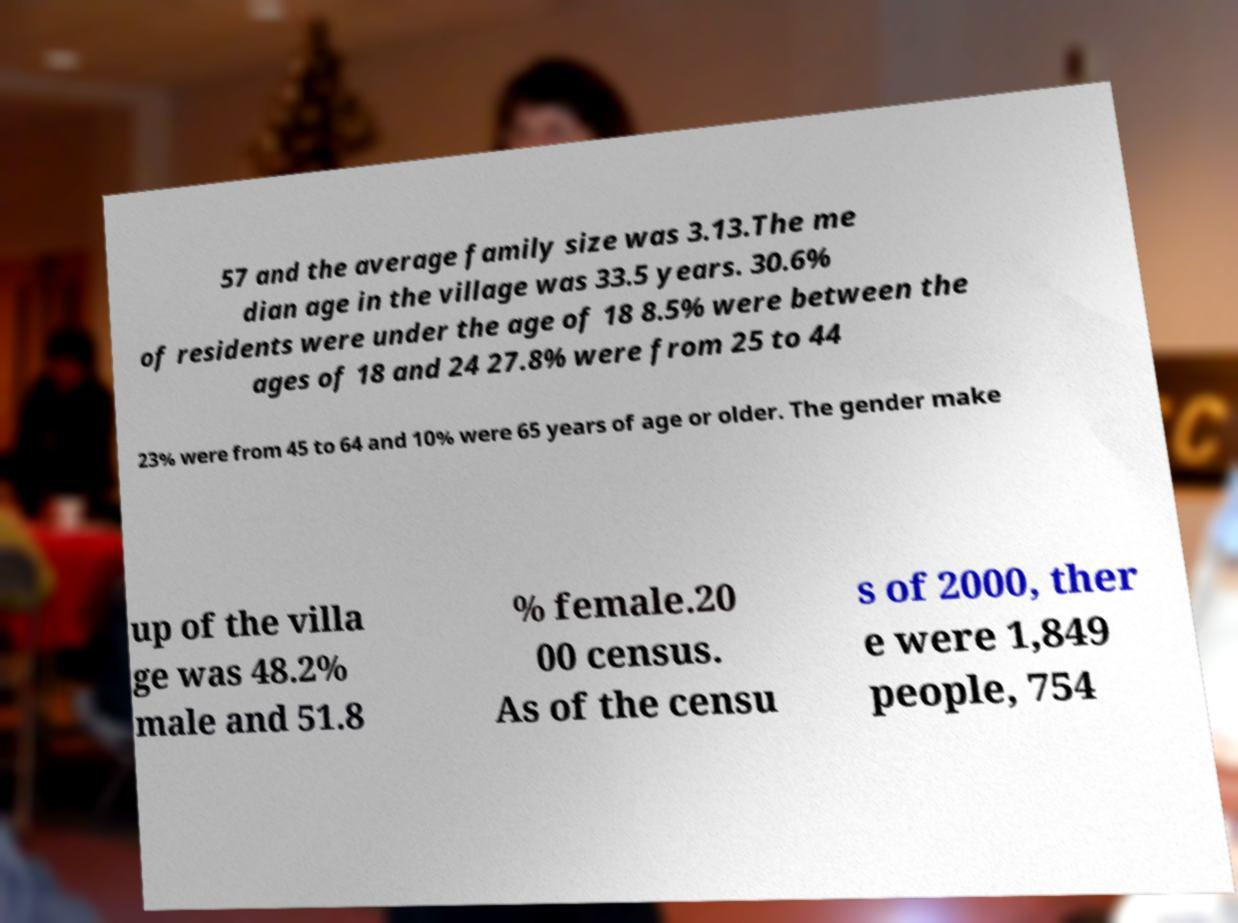Could you assist in decoding the text presented in this image and type it out clearly? 57 and the average family size was 3.13.The me dian age in the village was 33.5 years. 30.6% of residents were under the age of 18 8.5% were between the ages of 18 and 24 27.8% were from 25 to 44 23% were from 45 to 64 and 10% were 65 years of age or older. The gender make up of the villa ge was 48.2% male and 51.8 % female.20 00 census. As of the censu s of 2000, ther e were 1,849 people, 754 